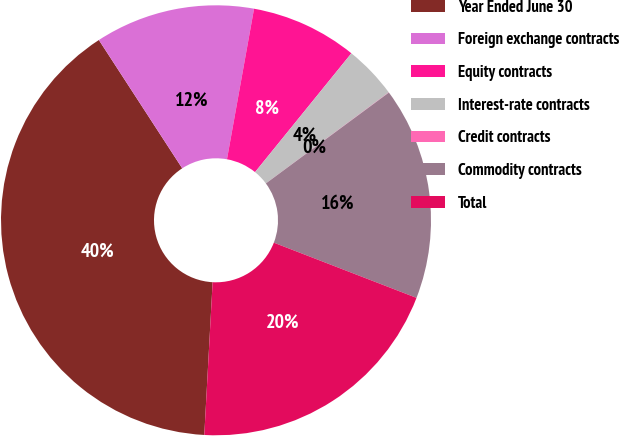Convert chart to OTSL. <chart><loc_0><loc_0><loc_500><loc_500><pie_chart><fcel>Year Ended June 30<fcel>Foreign exchange contracts<fcel>Equity contracts<fcel>Interest-rate contracts<fcel>Credit contracts<fcel>Commodity contracts<fcel>Total<nl><fcel>39.96%<fcel>12.0%<fcel>8.01%<fcel>4.01%<fcel>0.02%<fcel>16.0%<fcel>19.99%<nl></chart> 